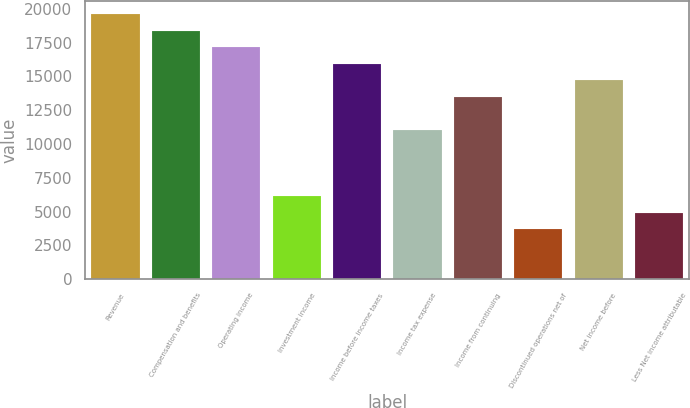<chart> <loc_0><loc_0><loc_500><loc_500><bar_chart><fcel>Revenue<fcel>Compensation and benefits<fcel>Operating income<fcel>Investment income<fcel>Income before income taxes<fcel>Income tax expense<fcel>Income from continuing<fcel>Discontinued operations net of<fcel>Net income before<fcel>Less Net income attributable<nl><fcel>19616.2<fcel>18390.3<fcel>17164.5<fcel>6131.72<fcel>15938.6<fcel>11035.2<fcel>13486.9<fcel>3680<fcel>14712.7<fcel>4905.86<nl></chart> 